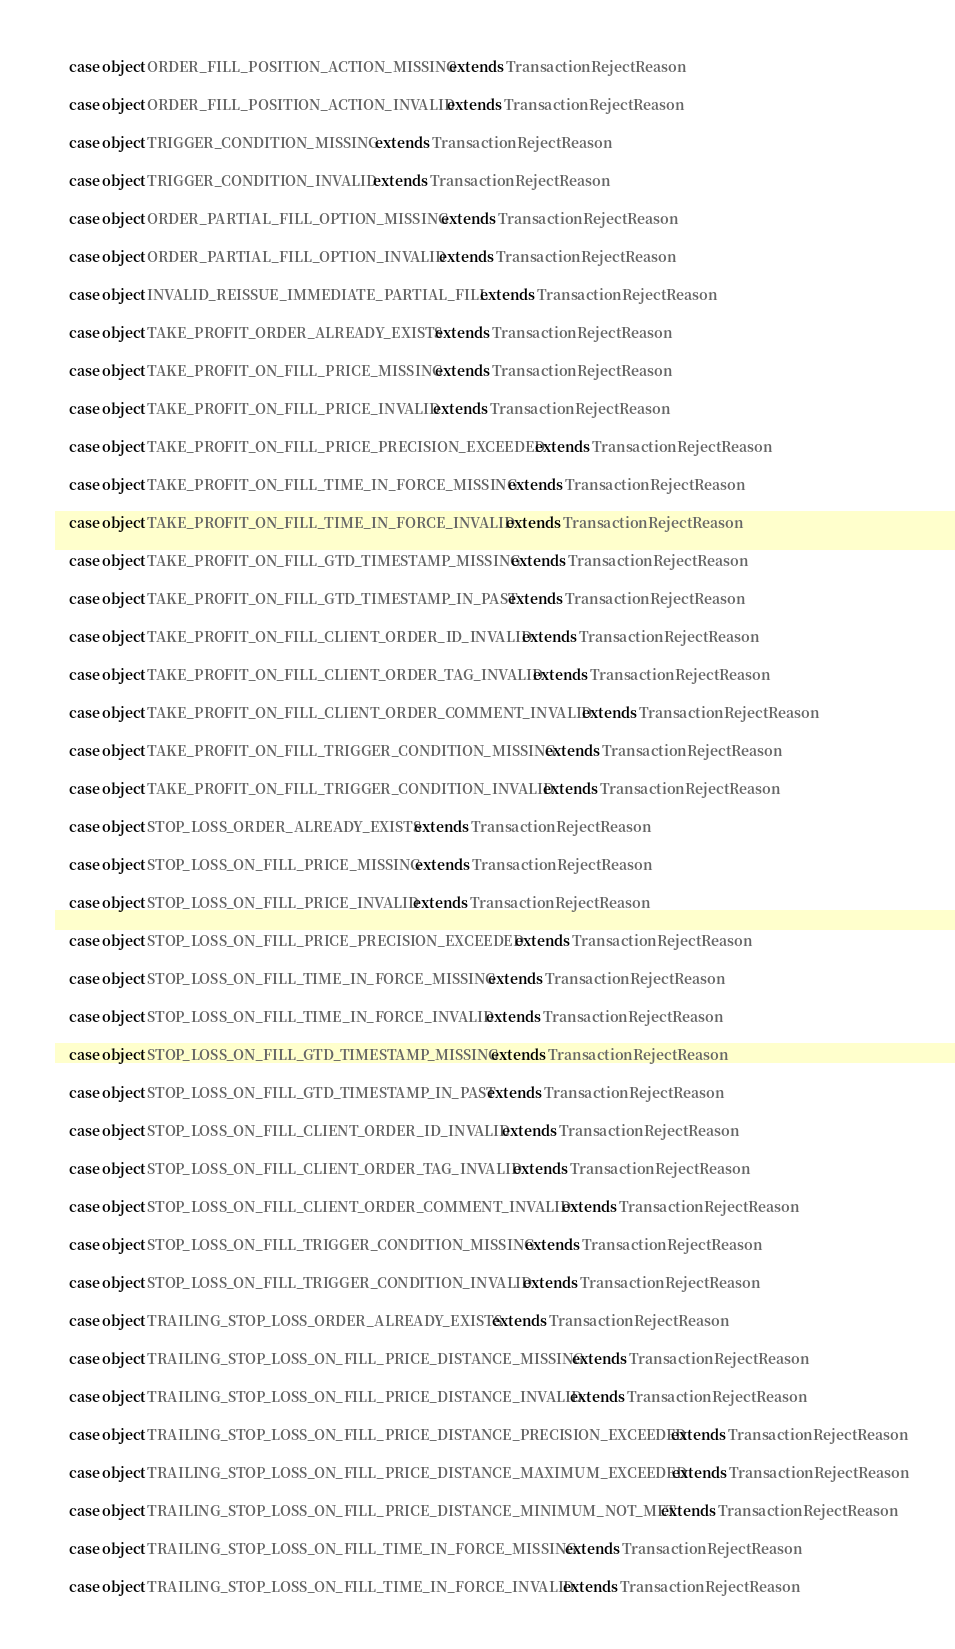Convert code to text. <code><loc_0><loc_0><loc_500><loc_500><_Scala_>
    case object ORDER_FILL_POSITION_ACTION_MISSING extends TransactionRejectReason

    case object ORDER_FILL_POSITION_ACTION_INVALID extends TransactionRejectReason

    case object TRIGGER_CONDITION_MISSING extends TransactionRejectReason

    case object TRIGGER_CONDITION_INVALID extends TransactionRejectReason

    case object ORDER_PARTIAL_FILL_OPTION_MISSING extends TransactionRejectReason

    case object ORDER_PARTIAL_FILL_OPTION_INVALID extends TransactionRejectReason

    case object INVALID_REISSUE_IMMEDIATE_PARTIAL_FILL extends TransactionRejectReason

    case object TAKE_PROFIT_ORDER_ALREADY_EXISTS extends TransactionRejectReason

    case object TAKE_PROFIT_ON_FILL_PRICE_MISSING extends TransactionRejectReason

    case object TAKE_PROFIT_ON_FILL_PRICE_INVALID extends TransactionRejectReason

    case object TAKE_PROFIT_ON_FILL_PRICE_PRECISION_EXCEEDED extends TransactionRejectReason

    case object TAKE_PROFIT_ON_FILL_TIME_IN_FORCE_MISSING extends TransactionRejectReason

    case object TAKE_PROFIT_ON_FILL_TIME_IN_FORCE_INVALID extends TransactionRejectReason

    case object TAKE_PROFIT_ON_FILL_GTD_TIMESTAMP_MISSING extends TransactionRejectReason

    case object TAKE_PROFIT_ON_FILL_GTD_TIMESTAMP_IN_PAST extends TransactionRejectReason

    case object TAKE_PROFIT_ON_FILL_CLIENT_ORDER_ID_INVALID extends TransactionRejectReason

    case object TAKE_PROFIT_ON_FILL_CLIENT_ORDER_TAG_INVALID extends TransactionRejectReason

    case object TAKE_PROFIT_ON_FILL_CLIENT_ORDER_COMMENT_INVALID extends TransactionRejectReason

    case object TAKE_PROFIT_ON_FILL_TRIGGER_CONDITION_MISSING extends TransactionRejectReason

    case object TAKE_PROFIT_ON_FILL_TRIGGER_CONDITION_INVALID extends TransactionRejectReason

    case object STOP_LOSS_ORDER_ALREADY_EXISTS extends TransactionRejectReason

    case object STOP_LOSS_ON_FILL_PRICE_MISSING extends TransactionRejectReason

    case object STOP_LOSS_ON_FILL_PRICE_INVALID extends TransactionRejectReason

    case object STOP_LOSS_ON_FILL_PRICE_PRECISION_EXCEEDED extends TransactionRejectReason

    case object STOP_LOSS_ON_FILL_TIME_IN_FORCE_MISSING extends TransactionRejectReason

    case object STOP_LOSS_ON_FILL_TIME_IN_FORCE_INVALID extends TransactionRejectReason

    case object STOP_LOSS_ON_FILL_GTD_TIMESTAMP_MISSING extends TransactionRejectReason

    case object STOP_LOSS_ON_FILL_GTD_TIMESTAMP_IN_PAST extends TransactionRejectReason

    case object STOP_LOSS_ON_FILL_CLIENT_ORDER_ID_INVALID extends TransactionRejectReason

    case object STOP_LOSS_ON_FILL_CLIENT_ORDER_TAG_INVALID extends TransactionRejectReason

    case object STOP_LOSS_ON_FILL_CLIENT_ORDER_COMMENT_INVALID extends TransactionRejectReason

    case object STOP_LOSS_ON_FILL_TRIGGER_CONDITION_MISSING extends TransactionRejectReason

    case object STOP_LOSS_ON_FILL_TRIGGER_CONDITION_INVALID extends TransactionRejectReason

    case object TRAILING_STOP_LOSS_ORDER_ALREADY_EXISTS extends TransactionRejectReason

    case object TRAILING_STOP_LOSS_ON_FILL_PRICE_DISTANCE_MISSING extends TransactionRejectReason

    case object TRAILING_STOP_LOSS_ON_FILL_PRICE_DISTANCE_INVALID extends TransactionRejectReason

    case object TRAILING_STOP_LOSS_ON_FILL_PRICE_DISTANCE_PRECISION_EXCEEDED extends TransactionRejectReason

    case object TRAILING_STOP_LOSS_ON_FILL_PRICE_DISTANCE_MAXIMUM_EXCEEDED extends TransactionRejectReason

    case object TRAILING_STOP_LOSS_ON_FILL_PRICE_DISTANCE_MINIMUM_NOT_MET extends TransactionRejectReason

    case object TRAILING_STOP_LOSS_ON_FILL_TIME_IN_FORCE_MISSING extends TransactionRejectReason

    case object TRAILING_STOP_LOSS_ON_FILL_TIME_IN_FORCE_INVALID extends TransactionRejectReason
</code> 